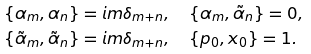<formula> <loc_0><loc_0><loc_500><loc_500>\{ \alpha _ { m } , \alpha _ { n } \} & = i m \delta _ { m + n } , \quad \{ \alpha _ { m } , \tilde { \alpha } _ { n } \} = 0 , \\ \{ \tilde { \alpha } _ { m } , \tilde { \alpha } _ { n } \} & = i m \delta _ { m + n } , \quad \{ p _ { 0 } , x _ { 0 } \} = 1 .</formula> 